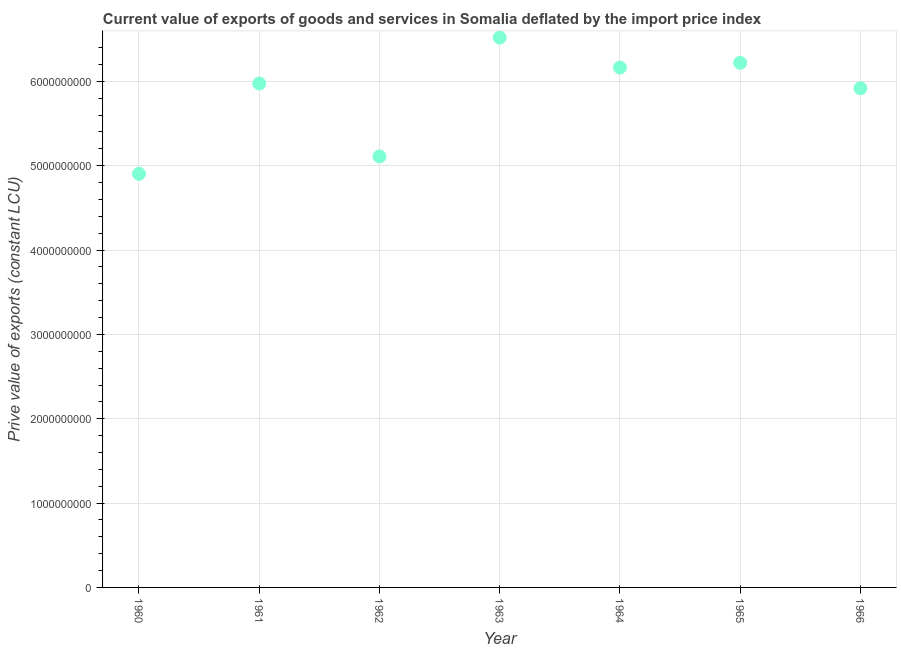What is the price value of exports in 1965?
Provide a short and direct response. 6.22e+09. Across all years, what is the maximum price value of exports?
Provide a short and direct response. 6.52e+09. Across all years, what is the minimum price value of exports?
Give a very brief answer. 4.90e+09. In which year was the price value of exports maximum?
Offer a very short reply. 1963. What is the sum of the price value of exports?
Keep it short and to the point. 4.08e+1. What is the difference between the price value of exports in 1963 and 1964?
Provide a short and direct response. 3.55e+08. What is the average price value of exports per year?
Give a very brief answer. 5.83e+09. What is the median price value of exports?
Offer a very short reply. 5.97e+09. In how many years, is the price value of exports greater than 5000000000 LCU?
Provide a succinct answer. 6. What is the ratio of the price value of exports in 1960 to that in 1962?
Make the answer very short. 0.96. Is the difference between the price value of exports in 1961 and 1964 greater than the difference between any two years?
Give a very brief answer. No. What is the difference between the highest and the second highest price value of exports?
Give a very brief answer. 2.98e+08. Is the sum of the price value of exports in 1965 and 1966 greater than the maximum price value of exports across all years?
Provide a succinct answer. Yes. What is the difference between the highest and the lowest price value of exports?
Your answer should be compact. 1.61e+09. In how many years, is the price value of exports greater than the average price value of exports taken over all years?
Provide a succinct answer. 5. Does the price value of exports monotonically increase over the years?
Offer a terse response. No. How many years are there in the graph?
Your answer should be compact. 7. Are the values on the major ticks of Y-axis written in scientific E-notation?
Ensure brevity in your answer.  No. Does the graph contain any zero values?
Ensure brevity in your answer.  No. Does the graph contain grids?
Your response must be concise. Yes. What is the title of the graph?
Your answer should be compact. Current value of exports of goods and services in Somalia deflated by the import price index. What is the label or title of the X-axis?
Ensure brevity in your answer.  Year. What is the label or title of the Y-axis?
Provide a succinct answer. Prive value of exports (constant LCU). What is the Prive value of exports (constant LCU) in 1960?
Keep it short and to the point. 4.90e+09. What is the Prive value of exports (constant LCU) in 1961?
Offer a terse response. 5.97e+09. What is the Prive value of exports (constant LCU) in 1962?
Give a very brief answer. 5.11e+09. What is the Prive value of exports (constant LCU) in 1963?
Keep it short and to the point. 6.52e+09. What is the Prive value of exports (constant LCU) in 1964?
Offer a terse response. 6.16e+09. What is the Prive value of exports (constant LCU) in 1965?
Provide a succinct answer. 6.22e+09. What is the Prive value of exports (constant LCU) in 1966?
Provide a short and direct response. 5.92e+09. What is the difference between the Prive value of exports (constant LCU) in 1960 and 1961?
Ensure brevity in your answer.  -1.07e+09. What is the difference between the Prive value of exports (constant LCU) in 1960 and 1962?
Keep it short and to the point. -2.06e+08. What is the difference between the Prive value of exports (constant LCU) in 1960 and 1963?
Ensure brevity in your answer.  -1.61e+09. What is the difference between the Prive value of exports (constant LCU) in 1960 and 1964?
Provide a succinct answer. -1.26e+09. What is the difference between the Prive value of exports (constant LCU) in 1960 and 1965?
Ensure brevity in your answer.  -1.32e+09. What is the difference between the Prive value of exports (constant LCU) in 1960 and 1966?
Provide a short and direct response. -1.01e+09. What is the difference between the Prive value of exports (constant LCU) in 1961 and 1962?
Provide a short and direct response. 8.65e+08. What is the difference between the Prive value of exports (constant LCU) in 1961 and 1963?
Provide a succinct answer. -5.44e+08. What is the difference between the Prive value of exports (constant LCU) in 1961 and 1964?
Offer a terse response. -1.89e+08. What is the difference between the Prive value of exports (constant LCU) in 1961 and 1965?
Provide a succinct answer. -2.46e+08. What is the difference between the Prive value of exports (constant LCU) in 1961 and 1966?
Provide a short and direct response. 5.59e+07. What is the difference between the Prive value of exports (constant LCU) in 1962 and 1963?
Make the answer very short. -1.41e+09. What is the difference between the Prive value of exports (constant LCU) in 1962 and 1964?
Your answer should be compact. -1.05e+09. What is the difference between the Prive value of exports (constant LCU) in 1962 and 1965?
Offer a terse response. -1.11e+09. What is the difference between the Prive value of exports (constant LCU) in 1962 and 1966?
Provide a short and direct response. -8.09e+08. What is the difference between the Prive value of exports (constant LCU) in 1963 and 1964?
Offer a terse response. 3.55e+08. What is the difference between the Prive value of exports (constant LCU) in 1963 and 1965?
Provide a short and direct response. 2.98e+08. What is the difference between the Prive value of exports (constant LCU) in 1963 and 1966?
Offer a very short reply. 6.00e+08. What is the difference between the Prive value of exports (constant LCU) in 1964 and 1965?
Make the answer very short. -5.68e+07. What is the difference between the Prive value of exports (constant LCU) in 1964 and 1966?
Offer a very short reply. 2.45e+08. What is the difference between the Prive value of exports (constant LCU) in 1965 and 1966?
Provide a succinct answer. 3.02e+08. What is the ratio of the Prive value of exports (constant LCU) in 1960 to that in 1961?
Provide a short and direct response. 0.82. What is the ratio of the Prive value of exports (constant LCU) in 1960 to that in 1963?
Your answer should be compact. 0.75. What is the ratio of the Prive value of exports (constant LCU) in 1960 to that in 1964?
Keep it short and to the point. 0.8. What is the ratio of the Prive value of exports (constant LCU) in 1960 to that in 1965?
Your answer should be compact. 0.79. What is the ratio of the Prive value of exports (constant LCU) in 1960 to that in 1966?
Make the answer very short. 0.83. What is the ratio of the Prive value of exports (constant LCU) in 1961 to that in 1962?
Offer a very short reply. 1.17. What is the ratio of the Prive value of exports (constant LCU) in 1961 to that in 1963?
Keep it short and to the point. 0.92. What is the ratio of the Prive value of exports (constant LCU) in 1961 to that in 1966?
Keep it short and to the point. 1.01. What is the ratio of the Prive value of exports (constant LCU) in 1962 to that in 1963?
Keep it short and to the point. 0.78. What is the ratio of the Prive value of exports (constant LCU) in 1962 to that in 1964?
Keep it short and to the point. 0.83. What is the ratio of the Prive value of exports (constant LCU) in 1962 to that in 1965?
Ensure brevity in your answer.  0.82. What is the ratio of the Prive value of exports (constant LCU) in 1962 to that in 1966?
Give a very brief answer. 0.86. What is the ratio of the Prive value of exports (constant LCU) in 1963 to that in 1964?
Your response must be concise. 1.06. What is the ratio of the Prive value of exports (constant LCU) in 1963 to that in 1965?
Offer a terse response. 1.05. What is the ratio of the Prive value of exports (constant LCU) in 1963 to that in 1966?
Provide a short and direct response. 1.1. What is the ratio of the Prive value of exports (constant LCU) in 1964 to that in 1965?
Ensure brevity in your answer.  0.99. What is the ratio of the Prive value of exports (constant LCU) in 1964 to that in 1966?
Offer a terse response. 1.04. What is the ratio of the Prive value of exports (constant LCU) in 1965 to that in 1966?
Your answer should be very brief. 1.05. 